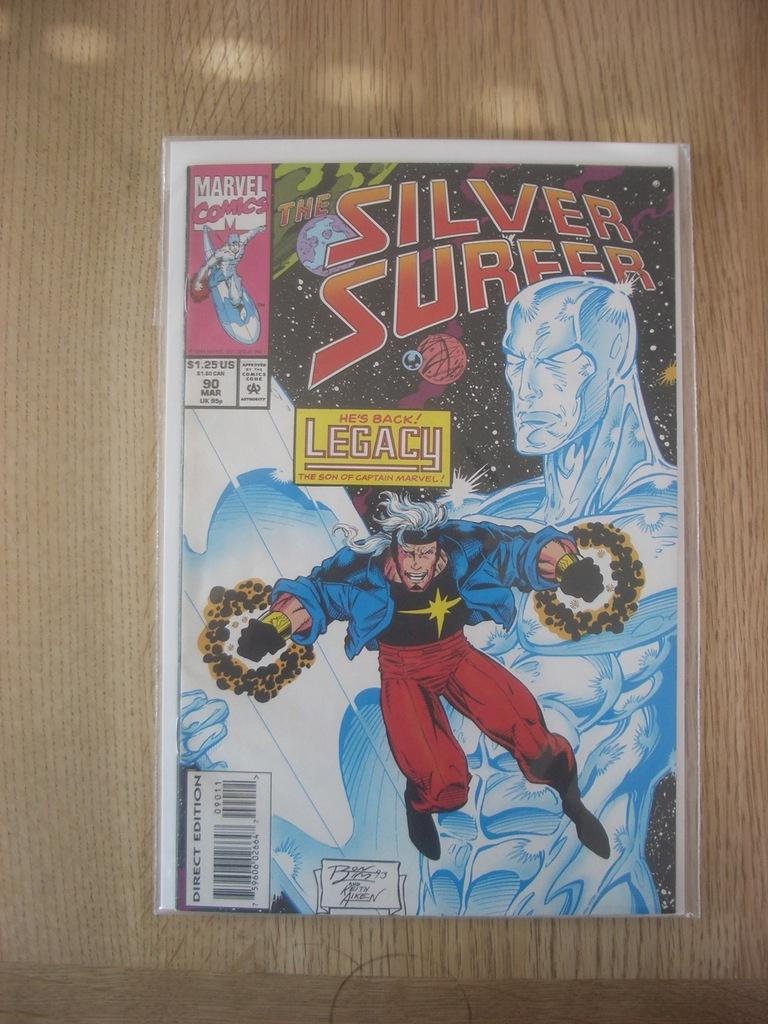<image>
Share a concise interpretation of the image provided. The Silver Surfer Marvel Comics book sitting on a table. 